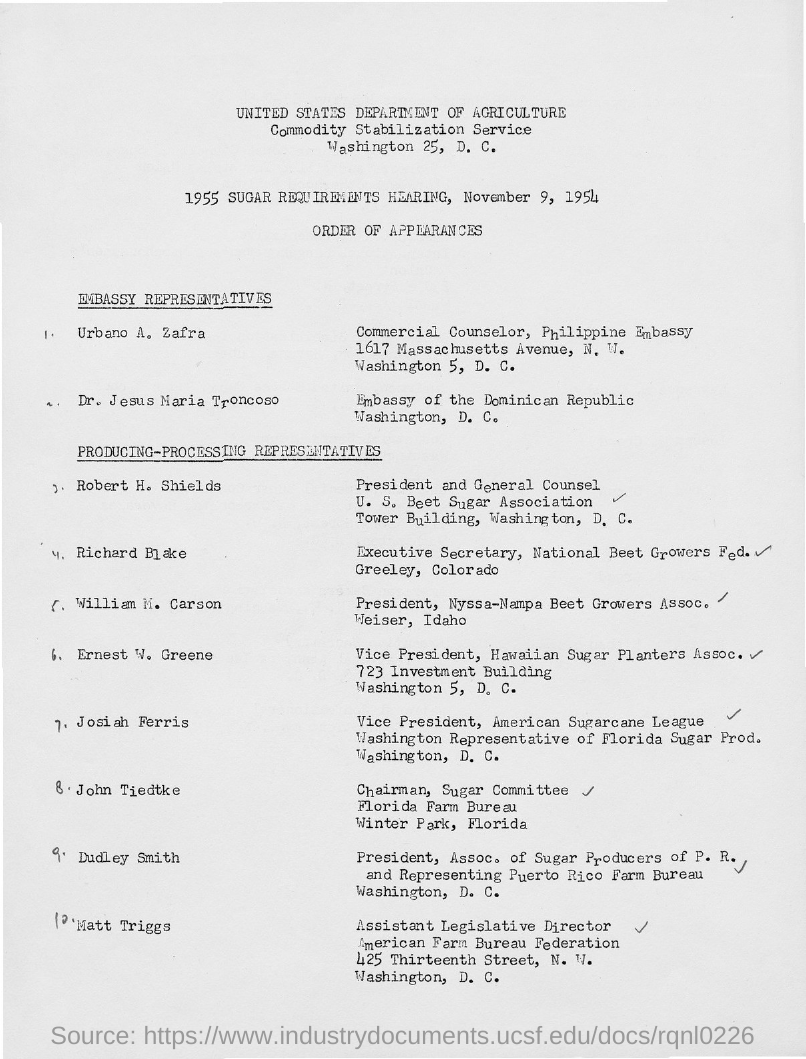Give some essential details in this illustration. William M. Carson holds the designation of Producing-Processing Representative. Urbano A. Zafra is the designated representative of the embassy. The 1955 Sugar Requirements Hearing was held on November 9, 1954. John Tiedtke is the Chairman of the Sugar Committee in Florida for the Farm Bureau. 